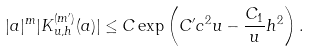Convert formula to latex. <formula><loc_0><loc_0><loc_500><loc_500>| a | ^ { m } | K _ { u , h } ^ { ( m ^ { \prime } ) } ( a ) | \leq C \exp \left ( C ^ { \prime } c ^ { 2 } u - \frac { C _ { 1 } } { u } h ^ { 2 } \right ) .</formula> 